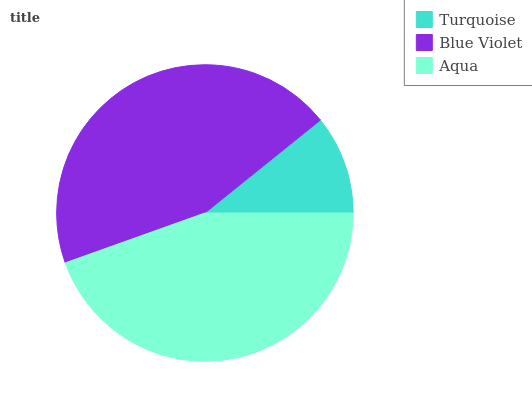Is Turquoise the minimum?
Answer yes or no. Yes. Is Blue Violet the maximum?
Answer yes or no. Yes. Is Aqua the minimum?
Answer yes or no. No. Is Aqua the maximum?
Answer yes or no. No. Is Blue Violet greater than Aqua?
Answer yes or no. Yes. Is Aqua less than Blue Violet?
Answer yes or no. Yes. Is Aqua greater than Blue Violet?
Answer yes or no. No. Is Blue Violet less than Aqua?
Answer yes or no. No. Is Aqua the high median?
Answer yes or no. Yes. Is Aqua the low median?
Answer yes or no. Yes. Is Blue Violet the high median?
Answer yes or no. No. Is Blue Violet the low median?
Answer yes or no. No. 